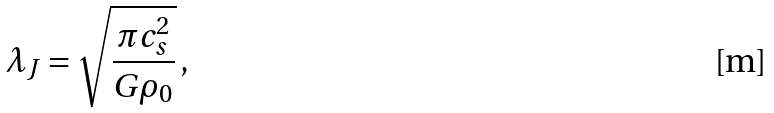<formula> <loc_0><loc_0><loc_500><loc_500>\lambda _ { J } = \sqrt { \frac { \pi c _ { s } ^ { 2 } } { G \rho _ { 0 } } } \, ,</formula> 